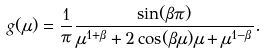Convert formula to latex. <formula><loc_0><loc_0><loc_500><loc_500>g ( \mu ) = \frac { 1 } { \pi } \frac { \sin ( \beta \pi ) } { \mu ^ { 1 + \beta } + 2 \cos ( \beta \mu ) \mu + \mu ^ { 1 - \beta } } .</formula> 